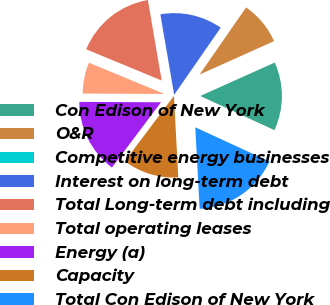Convert chart. <chart><loc_0><loc_0><loc_500><loc_500><pie_chart><fcel>Con Edison of New York<fcel>O&R<fcel>Competitive energy businesses<fcel>Interest on long-term debt<fcel>Total Long-term debt including<fcel>Total operating leases<fcel>Energy (a)<fcel>Capacity<fcel>Total Con Edison of New York<nl><fcel>13.58%<fcel>8.64%<fcel>0.0%<fcel>12.35%<fcel>16.05%<fcel>6.17%<fcel>14.81%<fcel>11.11%<fcel>17.28%<nl></chart> 